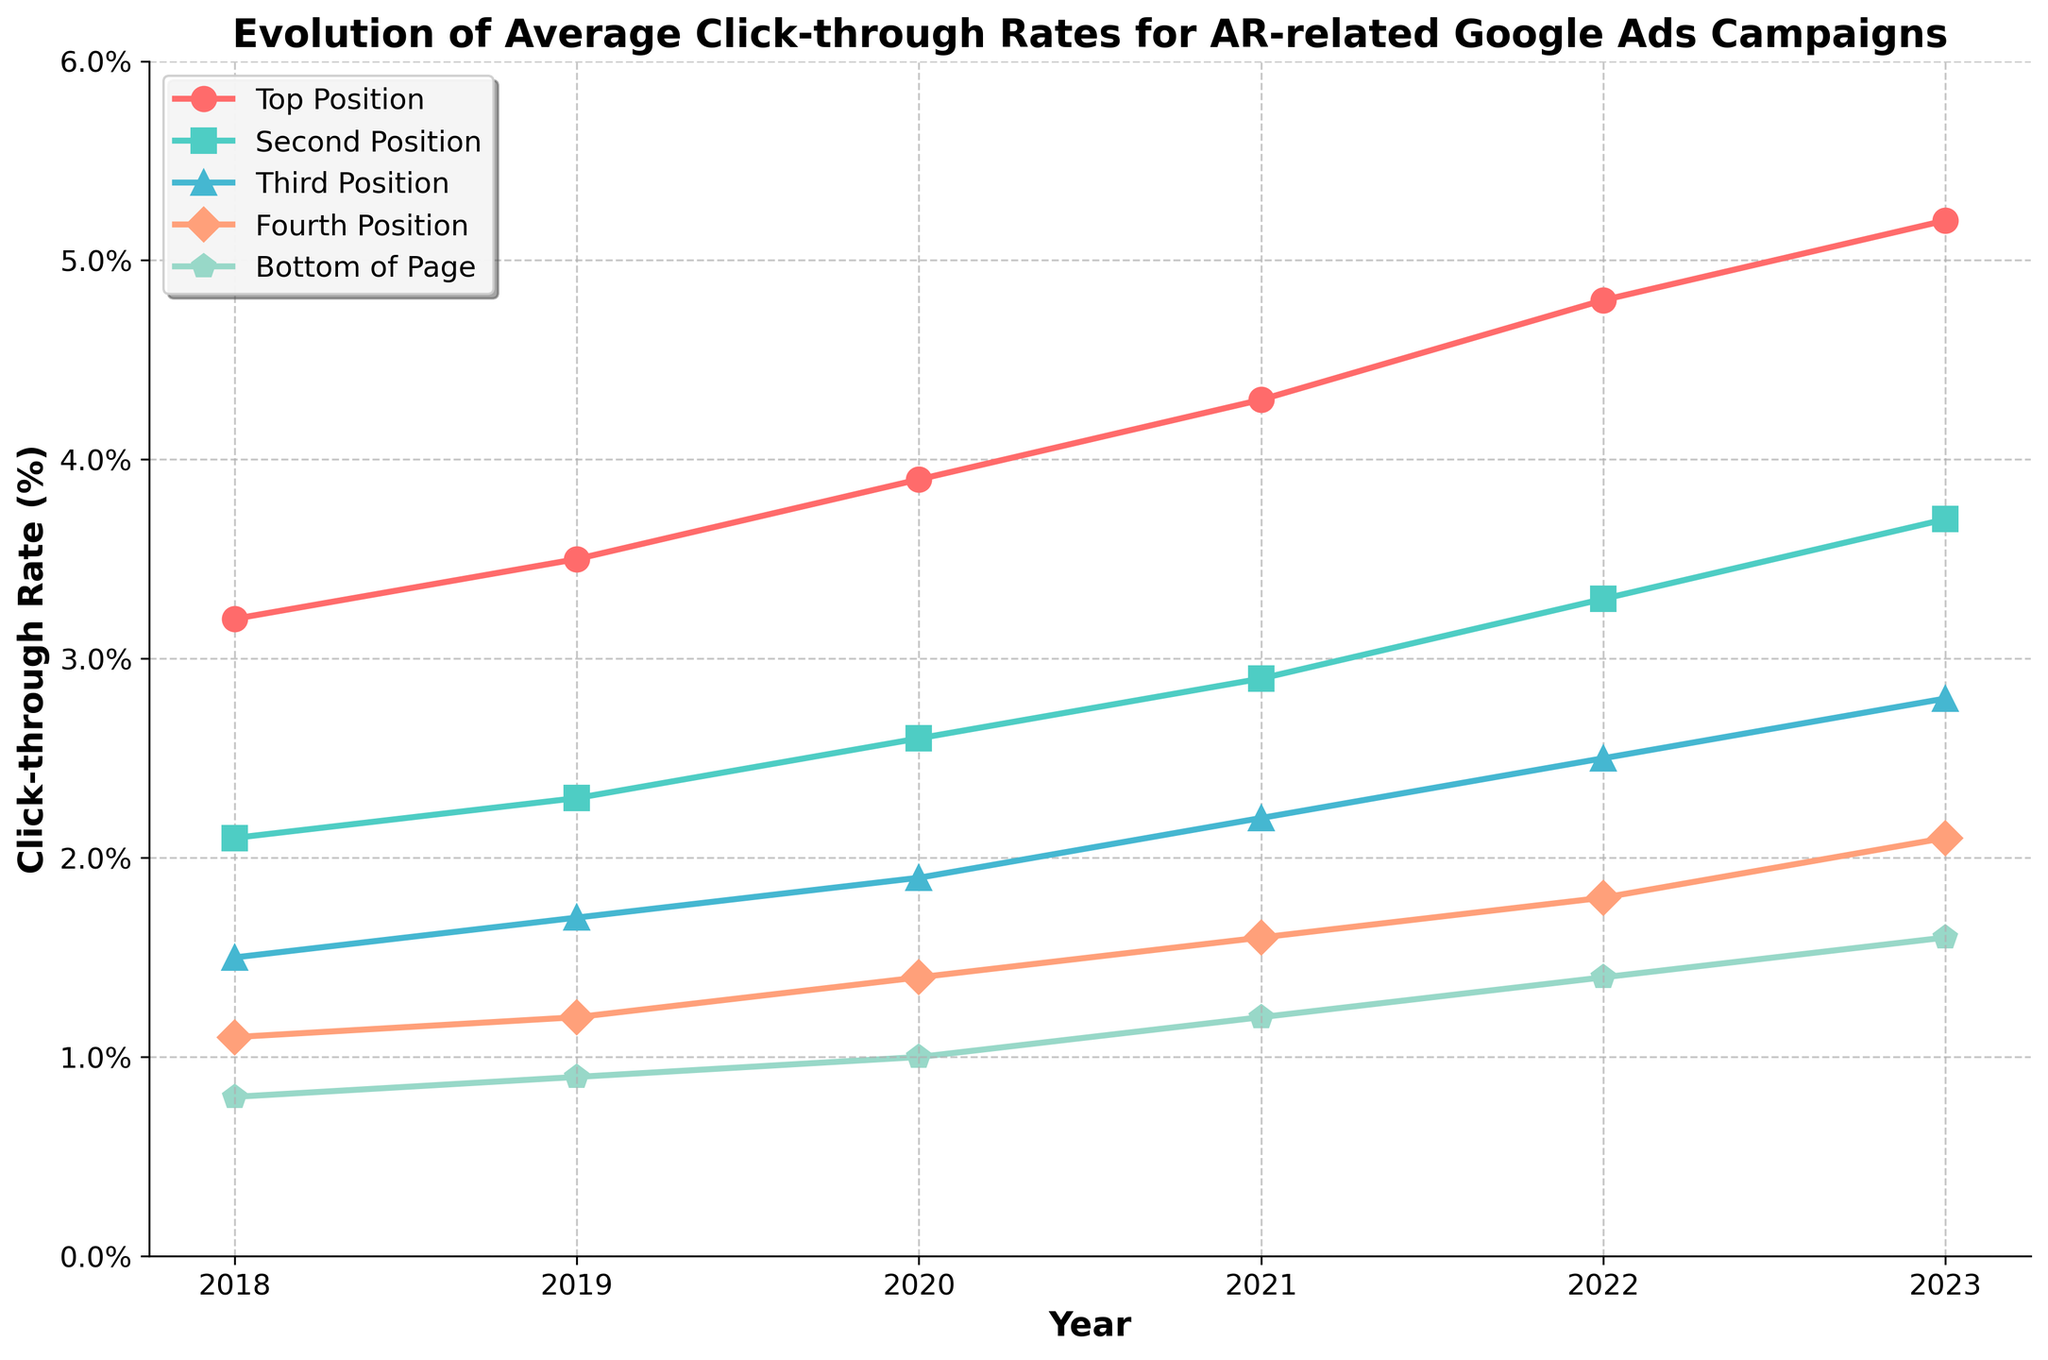Which ad position had the highest increase in click-through rate from 2018 to 2023? First, note the click-through rates for each position in 2018 and 2023: "Top Position" (3.2% to 5.2%), "Second Position" (2.1% to 3.7%), "Third Position" (1.5% to 2.8%), "Fourth Position" (1.1% to 2.1%), and "Bottom of Page" (0.8% to 1.6%). Calculate the increase: "Top Position" (2.0), "Second Position" (1.6), "Third Position" (1.3), "Fourth Position" (1.0), and "Bottom of Page" (0.8). "Top Position" has the highest increase.
Answer: Top Position What is the average click-through rate for the Third Position from 2018 to 2023? List the click-through rates for the Third Position: 1.5%, 1.7%, 1.9%, 2.2%, 2.5%, 2.8%. Convert to decimal: 0.015, 0.017, 0.019, 0.022, 0.025, 0.028. Calculate the average: (0.015 + 0.017 + 0.019 + 0.022 + 0.025 + 0.028) / 6 = 0.021. Convert back to percentage: 2.1%.
Answer: 2.1% In 2020, which ad position had a lower click-through rate: Second Position or Fourth Position? Refer to the 2020 click-through rates: "Second Position" (2.6%) and "Fourth Position" (1.4%). Compare these values.
Answer: Fourth Position Which ad position had the slowest growth in click-through rate between 2018 and 2023? Calculate the growth for each position: "Top Position" (2.0), "Second Position" (1.6), "Third Position" (1.3), "Fourth Position" (1.0), and "Bottom of Page" (0.8). The "Bottom of Page" position had the slowest growth.
Answer: Bottom of Page In what year did the click-through rate for the Second Position surpass 3%? Check the click-through rates for the "Second Position" for each year: 2018 (2.1%), 2019 (2.3%), 2020 (2.6%), 2021 (2.9%), 2022 (3.3%). The rate surpassed 3% in 2022.
Answer: 2022 Which two consecutive years showed the highest increase in click-through rate for the Top Position? Calculate the yearly increases for the Top Position: 2018-2019 (0.3), 2019-2020 (0.4), 2020-2021 (0.4), 2021-2022 (0.5), 2022-2023 (0.4). The highest increase between consecutive years is 2021-2022 (0.5).
Answer: 2021-2022 What is the average click-through rate for all positions in 2023? List the click-through rates for 2023: "Top Position" (5.2%), "Second Position" (3.7%), "Third Position" (2.8%), "Fourth Position" (2.1%), "Bottom of Page" (1.6%). Convert to decimal and calculate the average: (0.052 + 0.037 + 0.028 + 0.021 + 0.016) / 5 = 0.0308. Convert back to percentage: 3.08%.
Answer: 3.08% How did the click-through rate for the Fourth Position change from 2018 to 2020? List the click-through rates for the Fourth Position in 2018 and 2020: 1.1% and 1.4%. Calculate the change: (1.4% - 1.1%) = 0.3%.
Answer: 0.3% What was the click-through rate for the Third Position in 2019 and 2020, and what is the difference between them? Refer to the click-through rates for the Third Position in 2019 (1.7%) and 2020 (1.9%). Calculate the difference: 1.9% - 1.7% = 0.2%.
Answer: 0.2% Which ad position had the most consistent increase in click-through rate from 2018 to 2023? Calculate the yearly increases for each position and observe the consistency. "Top Position" (0.3, 0.4, 0.4, 0.5, 0.4), "Second Position" (0.2, 0.3, 0.3, 0.4, 0.4), "Third Position" (0.2, 0.2, 0.3, 0.3, 0.3), "Fourth Position" (0.1, 0.2, 0.2, 0.2, 0.3), "Bottom of Page" (0.1, 0.1, 0.2, 0.2, 0.2). The Third Position shows the most consistent yearly increase.
Answer: Third Position 